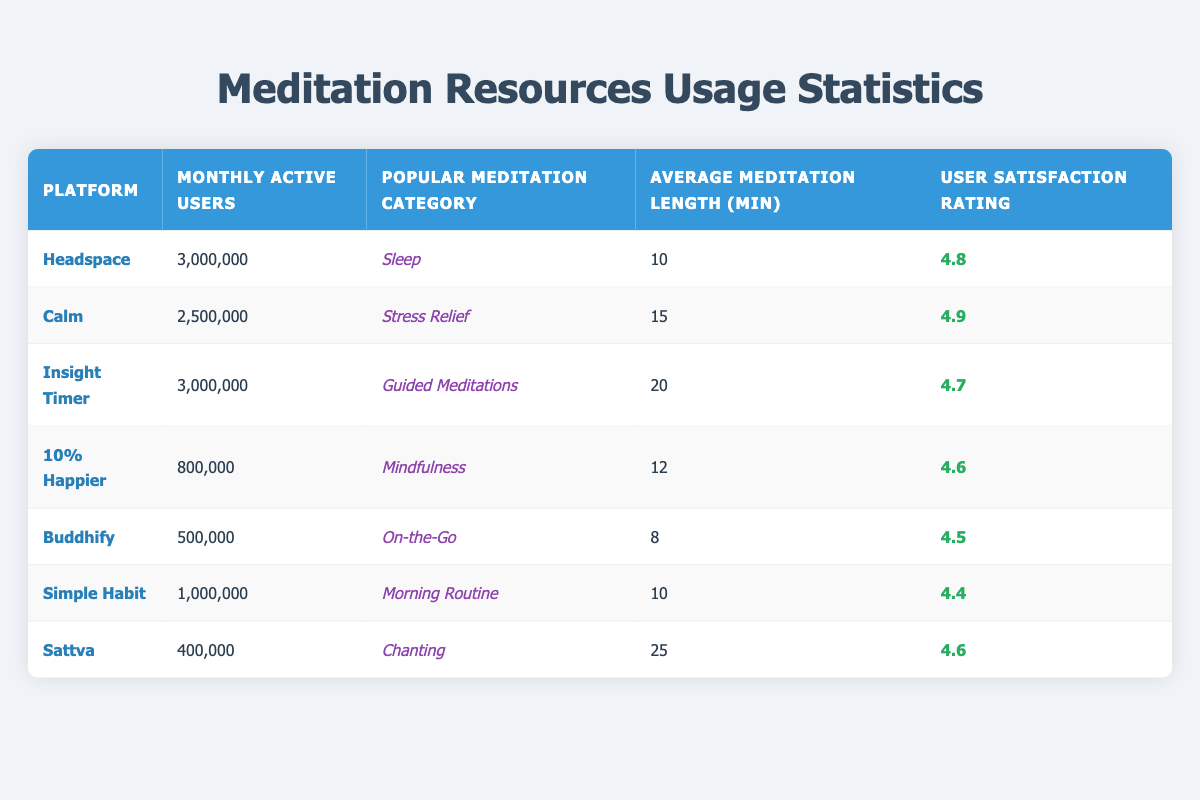What is the most popular meditation category on Calm? According to the table, the popular meditation category for Calm is listed as "Stress Relief."
Answer: Stress Relief How many monthly active users does Headspace have? The table states that Headspace has 3,000,000 monthly active users.
Answer: 3,000,000 Which platform has the highest user satisfaction rating? From the table, Calm has the highest user satisfaction rating of 4.9.
Answer: Calm What is the average meditation length across the platforms? To find the average, sum the average meditation lengths: (10 + 15 + 20 + 12 + 8 + 10 + 25) = 100. There are 7 platforms, so the average is 100 / 7 = approximately 14.29 minutes.
Answer: 14.29 minutes Is the user satisfaction rating for Insight Timer higher than that for 10% Happier? Insight Timer has a satisfaction rating of 4.7, while 10% Happier has a rating of 4.6. Since 4.7 is greater than 4.6, the statement is true.
Answer: Yes Which platform has the longest average meditation length? The table shows that Sattva has the longest average meditation length at 25 minutes.
Answer: Sattva How many more monthly active users does Insight Timer have than Buddhify? Insight Timer has 3,000,000 users, while Buddhify has 500,000 users. The difference is: 3,000,000 - 500,000 = 2,500,000.
Answer: 2,500,000 What percentage of users on all platforms use the Simple Habit app? Total monthly active users = 3,000,000 (Headspace) + 2,500,000 (Calm) + 3,000,000 (Insight Timer) + 800,000 (10% Happier) + 500,000 (Buddhify) + 1,000,000 (Simple Habit) + 400,000 (Sattva) = 11,200,000. The percentage of users on Simple Habit is then (1,000,000 / 11,200,000) * 100 = approximately 8.93%.
Answer: 8.93% Is there a platform with less than 500,000 monthly active users? The table indicates that Sattva has 400,000 monthly active users, which is less than 500,000, making the statement true.
Answer: Yes Which platform has the second most monthly active users? The monthly active users in descending order are: 3,000,000 (Headspace), 3,000,000 (Insight Timer), and 2,500,000 (Calm). Hence, Calm is the second in terms of monthly active users.
Answer: Calm 